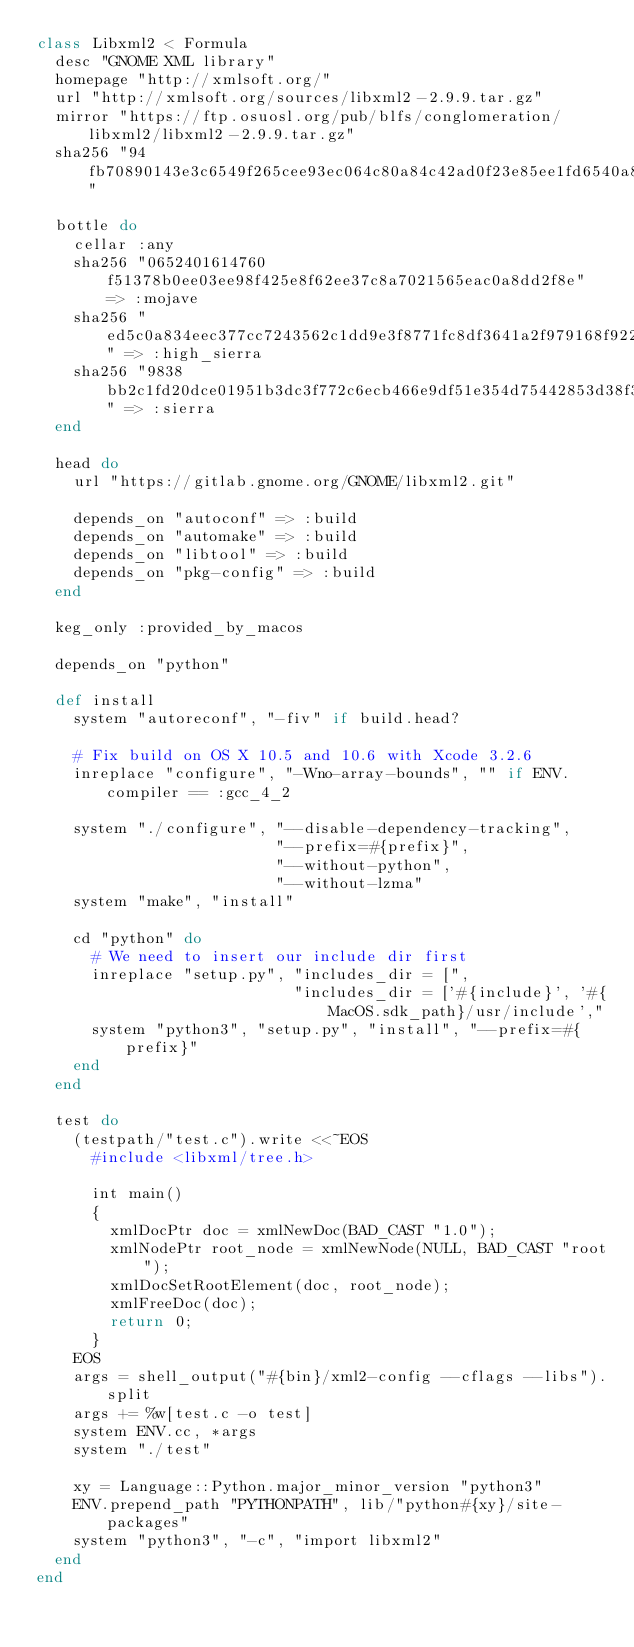<code> <loc_0><loc_0><loc_500><loc_500><_Ruby_>class Libxml2 < Formula
  desc "GNOME XML library"
  homepage "http://xmlsoft.org/"
  url "http://xmlsoft.org/sources/libxml2-2.9.9.tar.gz"
  mirror "https://ftp.osuosl.org/pub/blfs/conglomeration/libxml2/libxml2-2.9.9.tar.gz"
  sha256 "94fb70890143e3c6549f265cee93ec064c80a84c42ad0f23e85ee1fd6540a871"

  bottle do
    cellar :any
    sha256 "0652401614760f51378b0ee03ee98f425e8f62ee37c8a7021565eac0a8dd2f8e" => :mojave
    sha256 "ed5c0a834eec377cc7243562c1dd9e3f8771fc8df3641a2f979168f92243dc47" => :high_sierra
    sha256 "9838bb2c1fd20dce01951b3dc3f772c6ecb466e9df51e354d75442853d38f345" => :sierra
  end

  head do
    url "https://gitlab.gnome.org/GNOME/libxml2.git"

    depends_on "autoconf" => :build
    depends_on "automake" => :build
    depends_on "libtool" => :build
    depends_on "pkg-config" => :build
  end

  keg_only :provided_by_macos

  depends_on "python"

  def install
    system "autoreconf", "-fiv" if build.head?

    # Fix build on OS X 10.5 and 10.6 with Xcode 3.2.6
    inreplace "configure", "-Wno-array-bounds", "" if ENV.compiler == :gcc_4_2

    system "./configure", "--disable-dependency-tracking",
                          "--prefix=#{prefix}",
                          "--without-python",
                          "--without-lzma"
    system "make", "install"

    cd "python" do
      # We need to insert our include dir first
      inreplace "setup.py", "includes_dir = [",
                            "includes_dir = ['#{include}', '#{MacOS.sdk_path}/usr/include',"
      system "python3", "setup.py", "install", "--prefix=#{prefix}"
    end
  end

  test do
    (testpath/"test.c").write <<~EOS
      #include <libxml/tree.h>

      int main()
      {
        xmlDocPtr doc = xmlNewDoc(BAD_CAST "1.0");
        xmlNodePtr root_node = xmlNewNode(NULL, BAD_CAST "root");
        xmlDocSetRootElement(doc, root_node);
        xmlFreeDoc(doc);
        return 0;
      }
    EOS
    args = shell_output("#{bin}/xml2-config --cflags --libs").split
    args += %w[test.c -o test]
    system ENV.cc, *args
    system "./test"

    xy = Language::Python.major_minor_version "python3"
    ENV.prepend_path "PYTHONPATH", lib/"python#{xy}/site-packages"
    system "python3", "-c", "import libxml2"
  end
end
</code> 